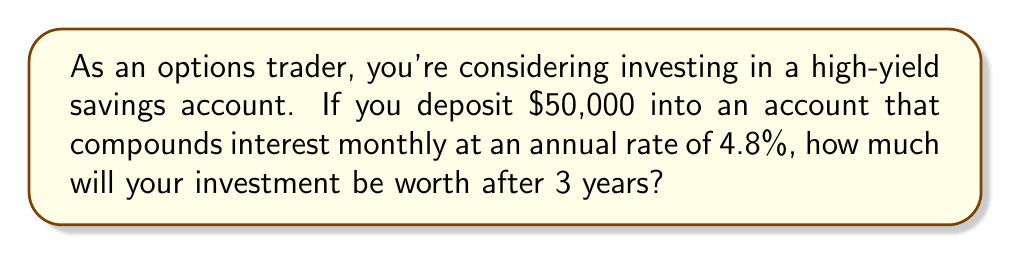Provide a solution to this math problem. To solve this problem, we'll use the compound interest formula:

$$A = P(1 + \frac{r}{n})^{nt}$$

Where:
$A$ = final amount
$P$ = principal (initial investment)
$r$ = annual interest rate (as a decimal)
$n$ = number of times interest is compounded per year
$t$ = number of years

Given:
$P = \$50,000$
$r = 4.8\% = 0.048$
$n = 12$ (compounded monthly)
$t = 3$ years

Let's substitute these values into the formula:

$$A = 50000(1 + \frac{0.048}{12})^{12 \cdot 3}$$

$$A = 50000(1 + 0.004)^{36}$$

$$A = 50000(1.004)^{36}$$

Using a calculator:

$$A = 50000 \cdot 1.1545$$

$$A = 57,725.00$$

Therefore, after 3 years, the investment will be worth $57,725.00.
Answer: $57,725.00 